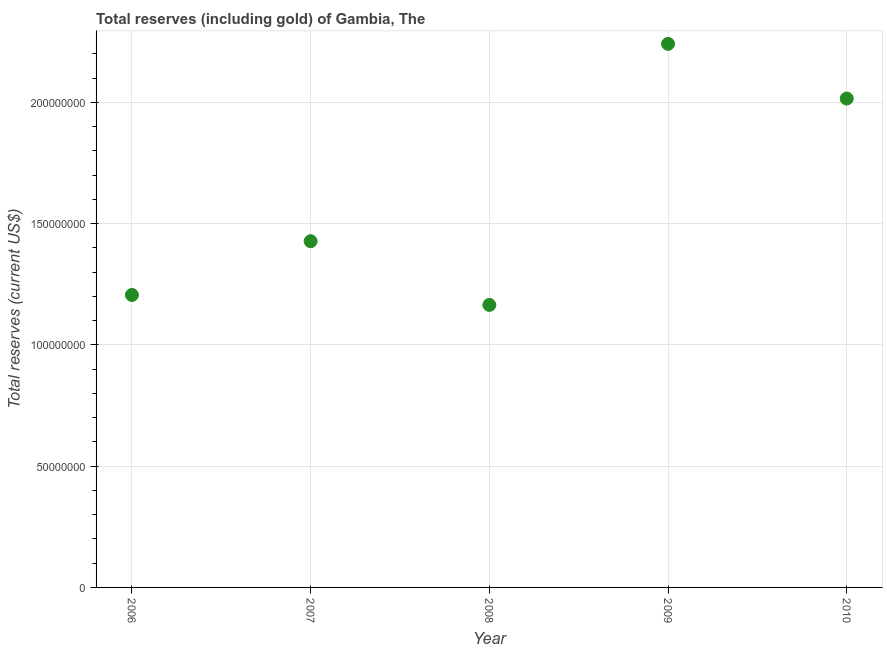What is the total reserves (including gold) in 2010?
Make the answer very short. 2.02e+08. Across all years, what is the maximum total reserves (including gold)?
Your answer should be very brief. 2.24e+08. Across all years, what is the minimum total reserves (including gold)?
Offer a very short reply. 1.17e+08. What is the sum of the total reserves (including gold)?
Your answer should be very brief. 8.06e+08. What is the difference between the total reserves (including gold) in 2007 and 2009?
Make the answer very short. -8.14e+07. What is the average total reserves (including gold) per year?
Offer a terse response. 1.61e+08. What is the median total reserves (including gold)?
Provide a succinct answer. 1.43e+08. In how many years, is the total reserves (including gold) greater than 160000000 US$?
Provide a short and direct response. 2. Do a majority of the years between 2009 and 2006 (inclusive) have total reserves (including gold) greater than 30000000 US$?
Provide a short and direct response. Yes. What is the ratio of the total reserves (including gold) in 2006 to that in 2009?
Make the answer very short. 0.54. Is the difference between the total reserves (including gold) in 2008 and 2009 greater than the difference between any two years?
Offer a very short reply. Yes. What is the difference between the highest and the second highest total reserves (including gold)?
Give a very brief answer. 2.25e+07. What is the difference between the highest and the lowest total reserves (including gold)?
Provide a succinct answer. 1.08e+08. Does the total reserves (including gold) monotonically increase over the years?
Offer a very short reply. No. How many dotlines are there?
Your answer should be very brief. 1. How many years are there in the graph?
Give a very brief answer. 5. What is the difference between two consecutive major ticks on the Y-axis?
Offer a terse response. 5.00e+07. Does the graph contain grids?
Keep it short and to the point. Yes. What is the title of the graph?
Keep it short and to the point. Total reserves (including gold) of Gambia, The. What is the label or title of the Y-axis?
Offer a terse response. Total reserves (current US$). What is the Total reserves (current US$) in 2006?
Give a very brief answer. 1.21e+08. What is the Total reserves (current US$) in 2007?
Keep it short and to the point. 1.43e+08. What is the Total reserves (current US$) in 2008?
Offer a terse response. 1.17e+08. What is the Total reserves (current US$) in 2009?
Keep it short and to the point. 2.24e+08. What is the Total reserves (current US$) in 2010?
Keep it short and to the point. 2.02e+08. What is the difference between the Total reserves (current US$) in 2006 and 2007?
Give a very brief answer. -2.22e+07. What is the difference between the Total reserves (current US$) in 2006 and 2008?
Your answer should be compact. 4.10e+06. What is the difference between the Total reserves (current US$) in 2006 and 2009?
Offer a very short reply. -1.04e+08. What is the difference between the Total reserves (current US$) in 2006 and 2010?
Your answer should be very brief. -8.10e+07. What is the difference between the Total reserves (current US$) in 2007 and 2008?
Offer a very short reply. 2.63e+07. What is the difference between the Total reserves (current US$) in 2007 and 2009?
Provide a short and direct response. -8.14e+07. What is the difference between the Total reserves (current US$) in 2007 and 2010?
Make the answer very short. -5.88e+07. What is the difference between the Total reserves (current US$) in 2008 and 2009?
Your answer should be compact. -1.08e+08. What is the difference between the Total reserves (current US$) in 2008 and 2010?
Ensure brevity in your answer.  -8.51e+07. What is the difference between the Total reserves (current US$) in 2009 and 2010?
Offer a terse response. 2.25e+07. What is the ratio of the Total reserves (current US$) in 2006 to that in 2007?
Give a very brief answer. 0.84. What is the ratio of the Total reserves (current US$) in 2006 to that in 2008?
Your answer should be very brief. 1.03. What is the ratio of the Total reserves (current US$) in 2006 to that in 2009?
Your answer should be very brief. 0.54. What is the ratio of the Total reserves (current US$) in 2006 to that in 2010?
Keep it short and to the point. 0.6. What is the ratio of the Total reserves (current US$) in 2007 to that in 2008?
Make the answer very short. 1.23. What is the ratio of the Total reserves (current US$) in 2007 to that in 2009?
Your answer should be very brief. 0.64. What is the ratio of the Total reserves (current US$) in 2007 to that in 2010?
Give a very brief answer. 0.71. What is the ratio of the Total reserves (current US$) in 2008 to that in 2009?
Ensure brevity in your answer.  0.52. What is the ratio of the Total reserves (current US$) in 2008 to that in 2010?
Keep it short and to the point. 0.58. What is the ratio of the Total reserves (current US$) in 2009 to that in 2010?
Give a very brief answer. 1.11. 